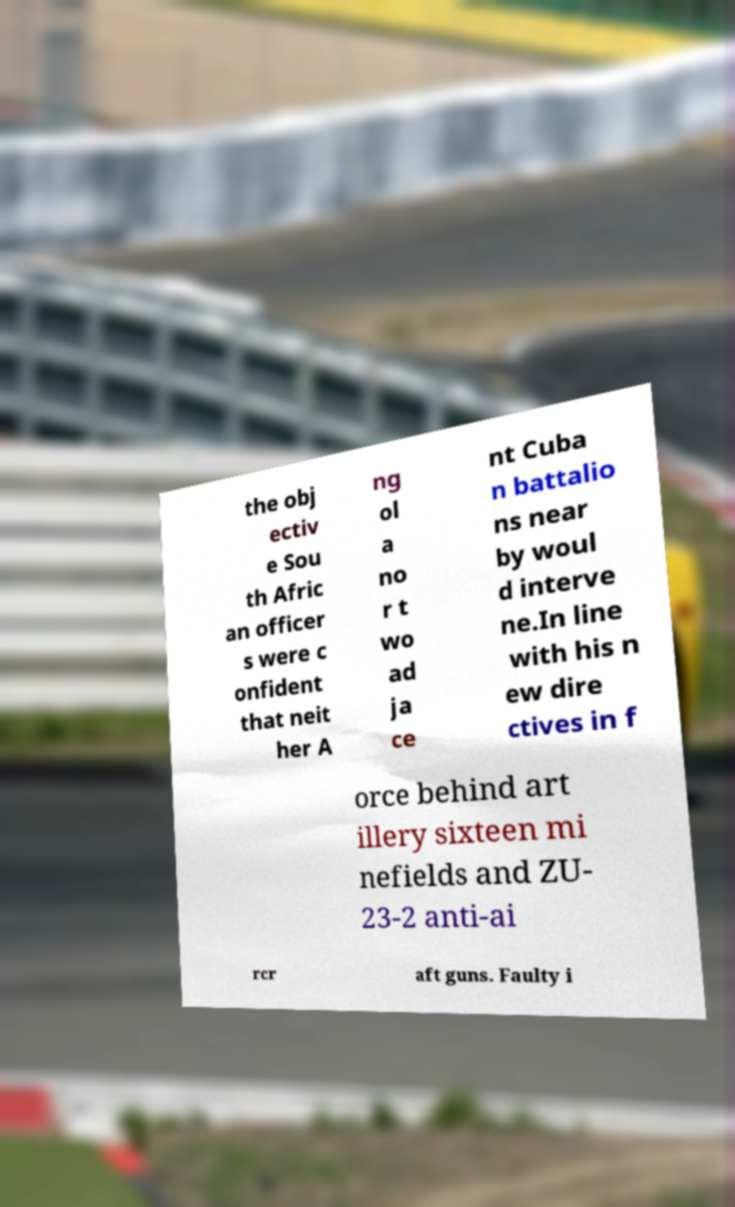What messages or text are displayed in this image? I need them in a readable, typed format. the obj ectiv e Sou th Afric an officer s were c onfident that neit her A ng ol a no r t wo ad ja ce nt Cuba n battalio ns near by woul d interve ne.In line with his n ew dire ctives in f orce behind art illery sixteen mi nefields and ZU- 23-2 anti-ai rcr aft guns. Faulty i 